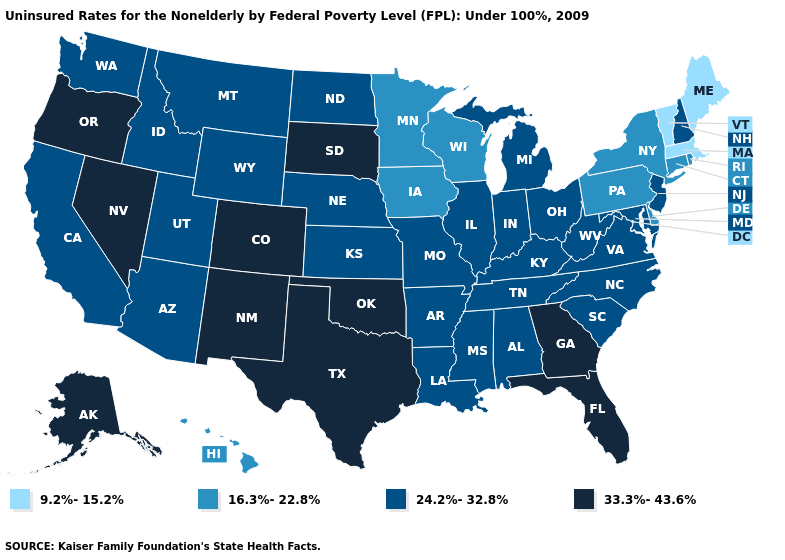Does Alaska have the highest value in the USA?
Write a very short answer. Yes. What is the value of New Mexico?
Short answer required. 33.3%-43.6%. Which states have the highest value in the USA?
Keep it brief. Alaska, Colorado, Florida, Georgia, Nevada, New Mexico, Oklahoma, Oregon, South Dakota, Texas. What is the value of Texas?
Quick response, please. 33.3%-43.6%. Which states hav the highest value in the MidWest?
Quick response, please. South Dakota. Name the states that have a value in the range 9.2%-15.2%?
Concise answer only. Maine, Massachusetts, Vermont. Which states have the lowest value in the USA?
Be succinct. Maine, Massachusetts, Vermont. Name the states that have a value in the range 33.3%-43.6%?
Quick response, please. Alaska, Colorado, Florida, Georgia, Nevada, New Mexico, Oklahoma, Oregon, South Dakota, Texas. What is the value of Ohio?
Write a very short answer. 24.2%-32.8%. Does the first symbol in the legend represent the smallest category?
Keep it brief. Yes. What is the highest value in states that border Delaware?
Be succinct. 24.2%-32.8%. Does New Hampshire have a lower value than West Virginia?
Short answer required. No. Does the first symbol in the legend represent the smallest category?
Quick response, please. Yes. Name the states that have a value in the range 33.3%-43.6%?
Concise answer only. Alaska, Colorado, Florida, Georgia, Nevada, New Mexico, Oklahoma, Oregon, South Dakota, Texas. Which states have the highest value in the USA?
Give a very brief answer. Alaska, Colorado, Florida, Georgia, Nevada, New Mexico, Oklahoma, Oregon, South Dakota, Texas. 